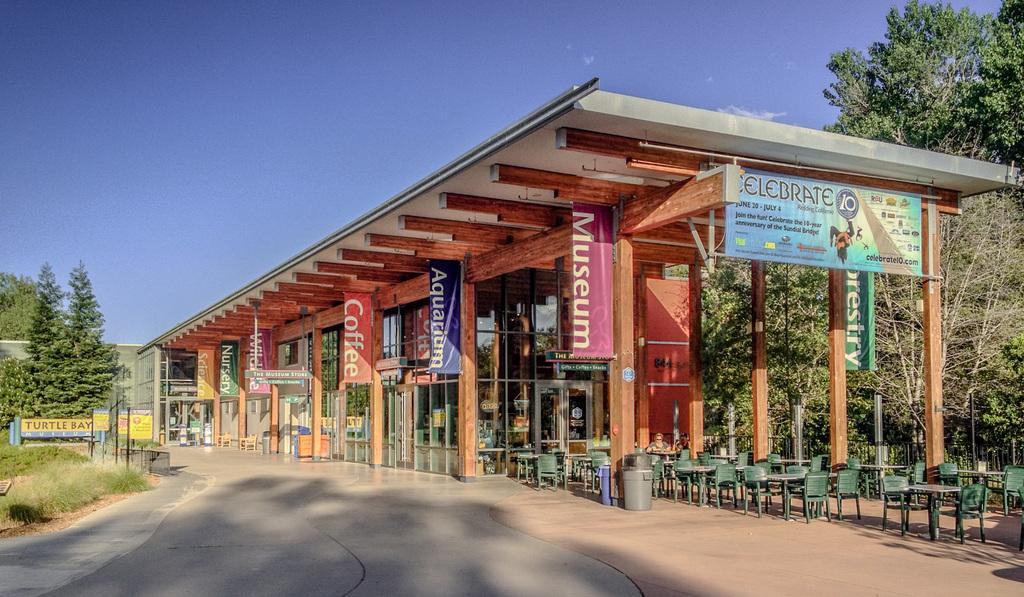What type of establishment is located in the center of the image? There is a restaurant in the center of the image. What furniture is present in the image? There are tables and chairs in the image. What type of vegetation can be seen in the image? There are trees in the image. What type of pathway is visible in the image? There is a road in the image. Can you tell me how many buttons are on the boy's shirt in the image? There is no boy or shirt with buttons present in the image. 